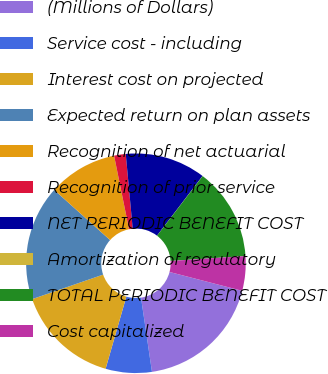Convert chart. <chart><loc_0><loc_0><loc_500><loc_500><pie_chart><fcel>(Millions of Dollars)<fcel>Service cost - including<fcel>Interest cost on projected<fcel>Expected return on plan assets<fcel>Recognition of net actuarial<fcel>Recognition of prior service<fcel>NET PERIODIC BENEFIT COST<fcel>Amortization of regulatory<fcel>TOTAL PERIODIC BENEFIT COST<fcel>Cost capitalized<nl><fcel>18.63%<fcel>6.79%<fcel>15.25%<fcel>16.94%<fcel>10.17%<fcel>1.71%<fcel>11.86%<fcel>0.02%<fcel>13.55%<fcel>5.09%<nl></chart> 